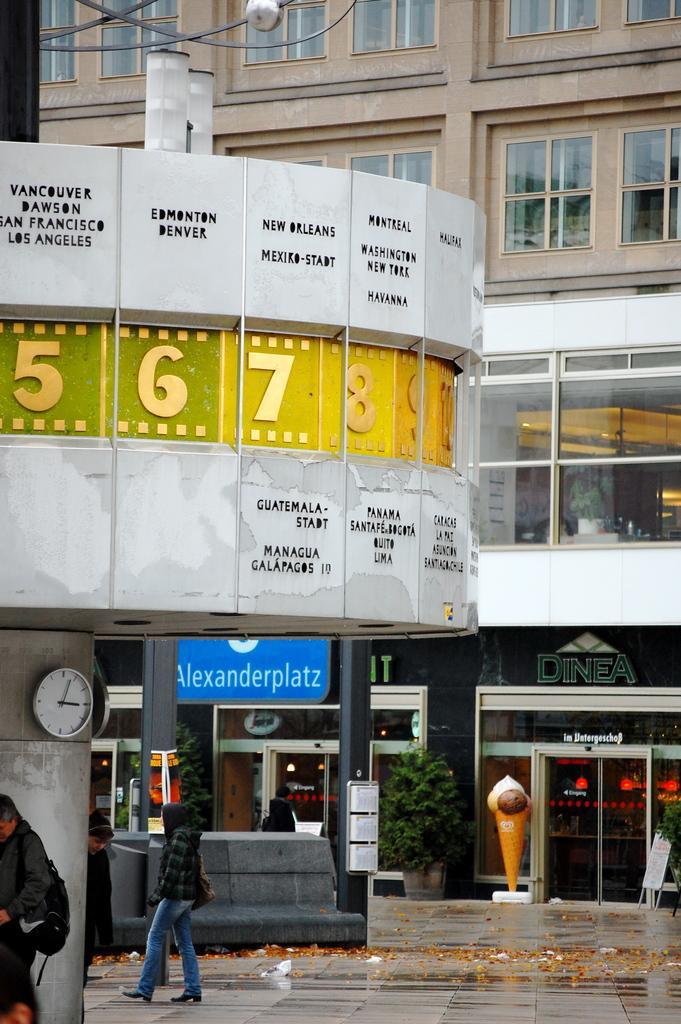Can you describe this image briefly? In the background of the image there is a building with windows. There are stalls. In the center of the image there are people walking on the floor. There is a clock. 